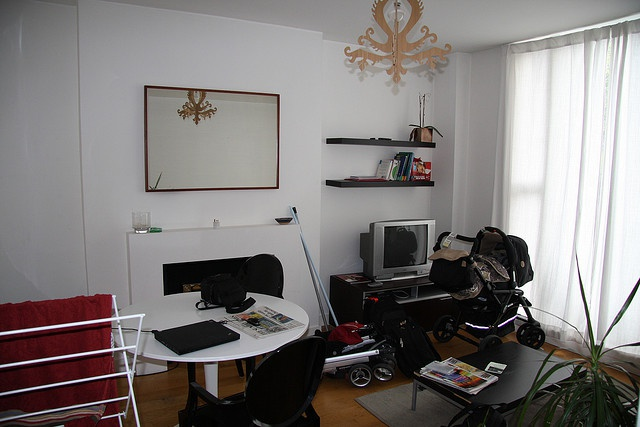Describe the objects in this image and their specific colors. I can see dining table in black, darkgray, gray, and lightgray tones, potted plant in black, gray, white, and darkgreen tones, chair in black, maroon, and gray tones, tv in black, gray, darkgray, and lightgray tones, and backpack in black, gray, and darkgray tones in this image. 